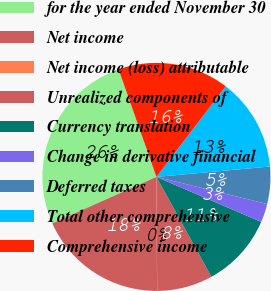Convert chart. <chart><loc_0><loc_0><loc_500><loc_500><pie_chart><fcel>for the year ended November 30<fcel>Net income<fcel>Net income (loss) attributable<fcel>Unrealized components of<fcel>Currency translation<fcel>Change in derivative financial<fcel>Deferred taxes<fcel>Total other comprehensive<fcel>Comprehensive income<nl><fcel>26.29%<fcel>18.41%<fcel>0.02%<fcel>7.9%<fcel>10.53%<fcel>2.64%<fcel>5.27%<fcel>13.15%<fcel>15.78%<nl></chart> 